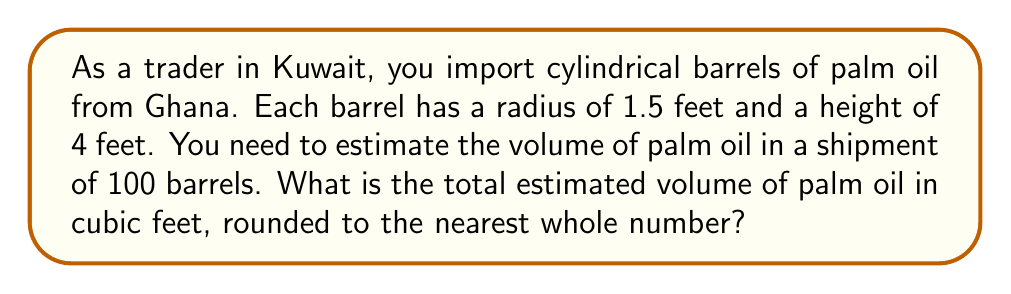Show me your answer to this math problem. To solve this problem, we'll follow these steps:

1. Recall the formula for the volume of a cylinder:
   $$V = \pi r^2 h$$
   where $V$ is volume, $r$ is radius, and $h$ is height.

2. Substitute the given values:
   $r = 1.5$ feet
   $h = 4$ feet

3. Calculate the volume of one barrel:
   $$V = \pi (1.5\text{ ft})^2 (4\text{ ft})$$
   $$V = \pi (2.25\text{ ft}^2) (4\text{ ft})$$
   $$V = 9\pi\text{ ft}^3$$

4. Evaluate $9\pi$:
   $$V \approx 28.27\text{ ft}^3$$

5. Multiply by the number of barrels (100):
   $$\text{Total Volume} = 28.27\text{ ft}^3 \times 100 = 2,827\text{ ft}^3$$

6. Round to the nearest whole number:
   $$\text{Total Volume} \approx 2,827\text{ ft}^3$$
Answer: 2,827 cubic feet 